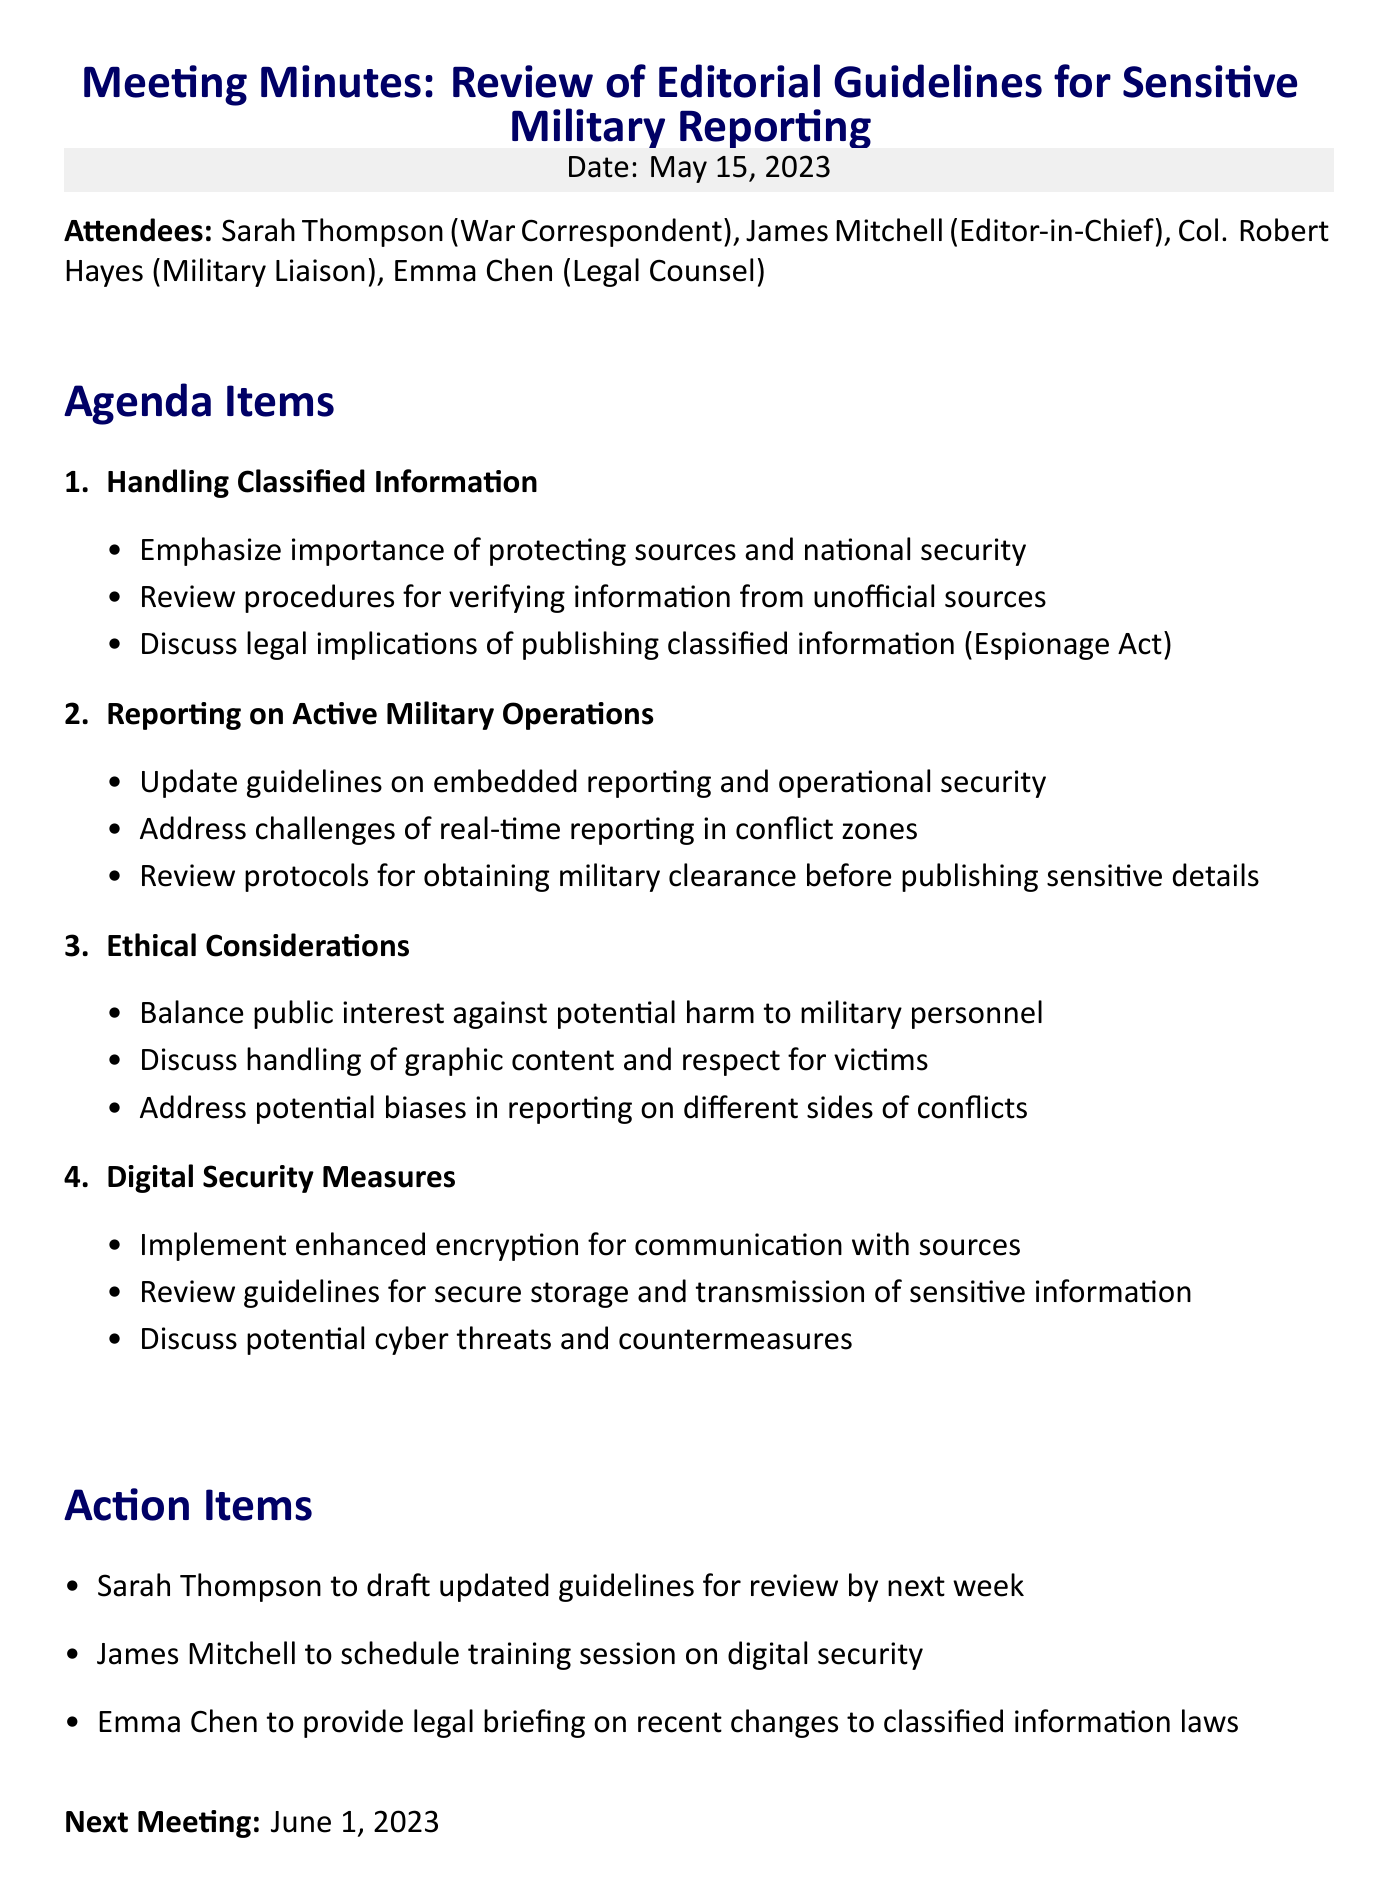What is the date of the meeting? The date of the meeting is specified in the document.
Answer: May 15, 2023 Who is the Editor-in-Chief? The document lists the attendees, including their roles and names.
Answer: James Mitchell What is one key point about handling classified information? The key points under handling classified information provide important guidelines.
Answer: Emphasize the importance of protecting sources and national security What is one ethical consideration discussed? The ethical considerations listed include various important aspects of reporting.
Answer: Balance public interest against potential harm to military personnel What action item is assigned to Sarah Thompson? The action items specify responsibilities for attendees following the meeting.
Answer: Sarah Thompson to draft updated guidelines for review by next week How many agenda items were discussed? The document outlines a specific number of agenda items in a list format.
Answer: Four When is the next meeting scheduled? The document specifies the date of the next meeting clearly.
Answer: June 1, 2023 What security measure is recommended for communication with sources? The digital security measures provide specific recommendations.
Answer: Implement enhanced encryption for communication with sources What legal implications were discussed regarding classified information? The meeting addressed specific legal considerations related to publishing sensitive content.
Answer: Discuss legal implications of publishing classified information (Espionage Act) 